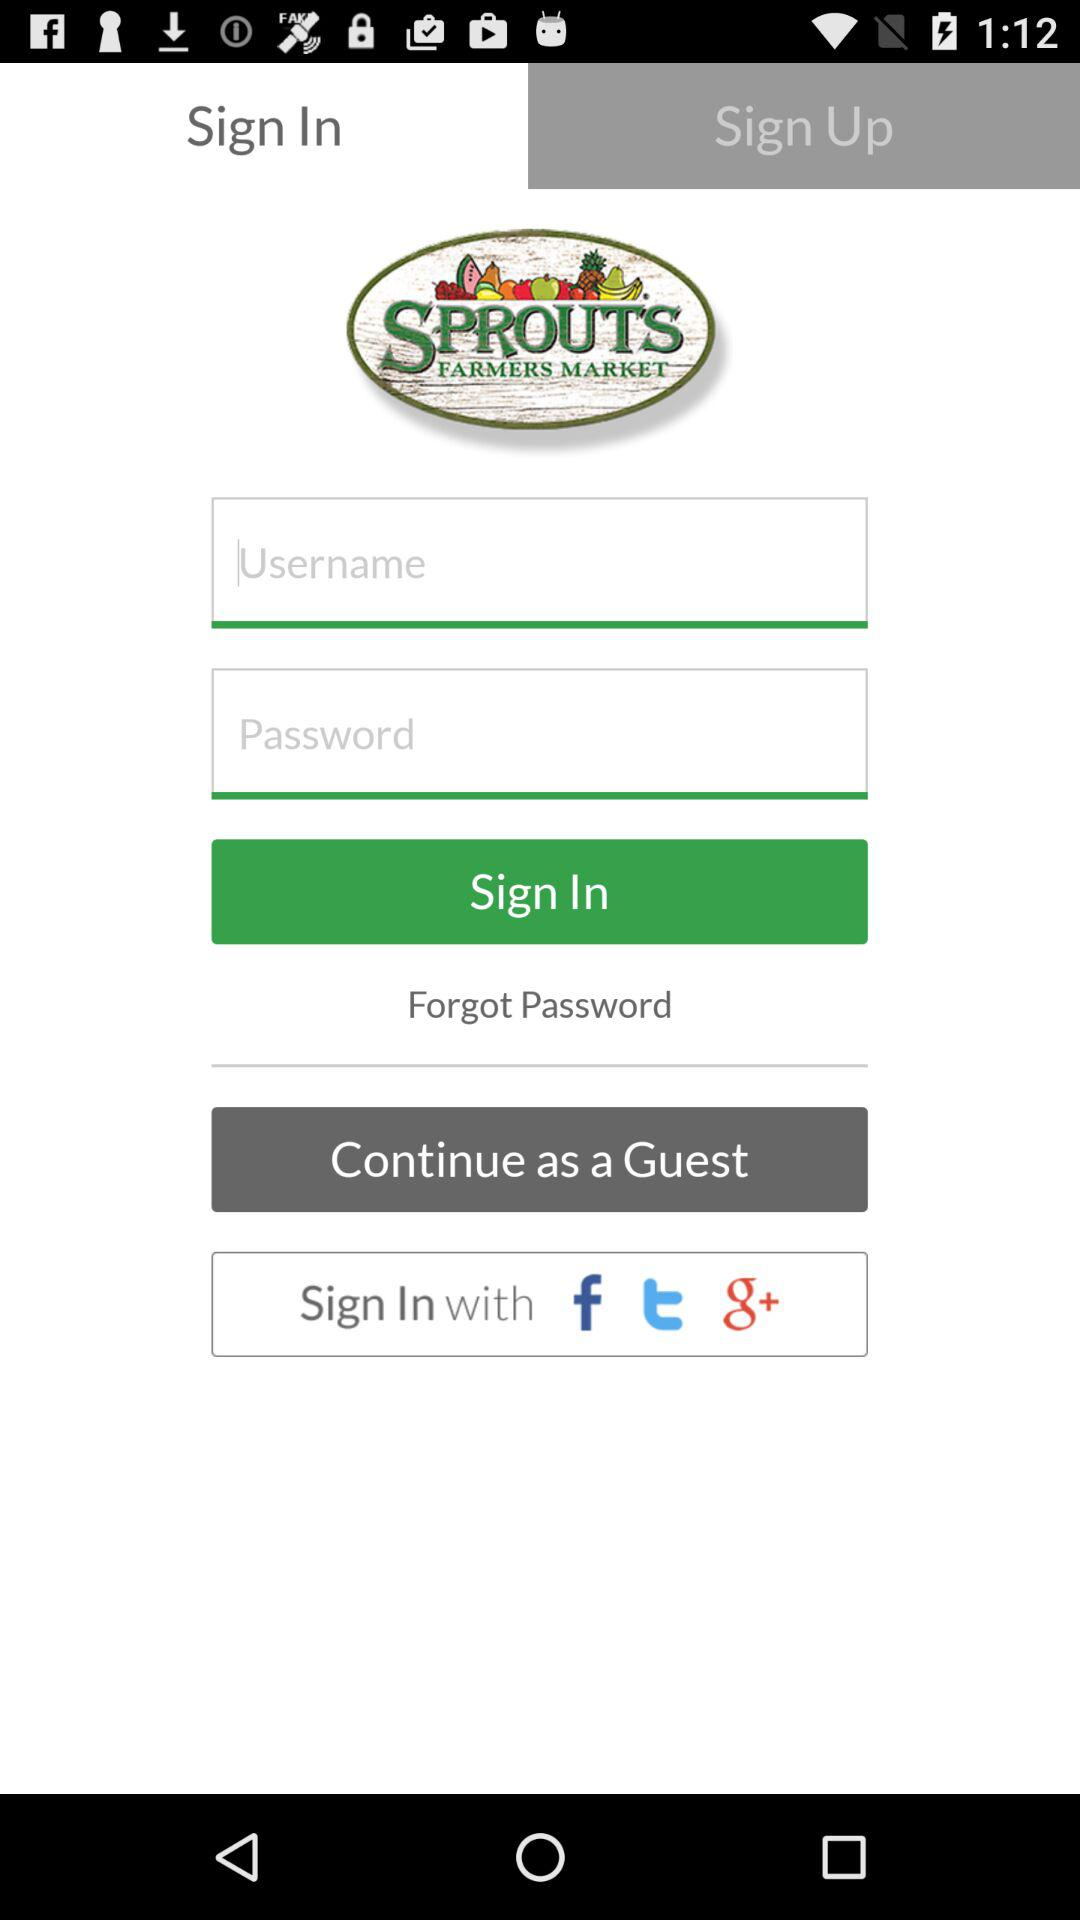Which tab am I on? You are on the "Sign In" tab. 